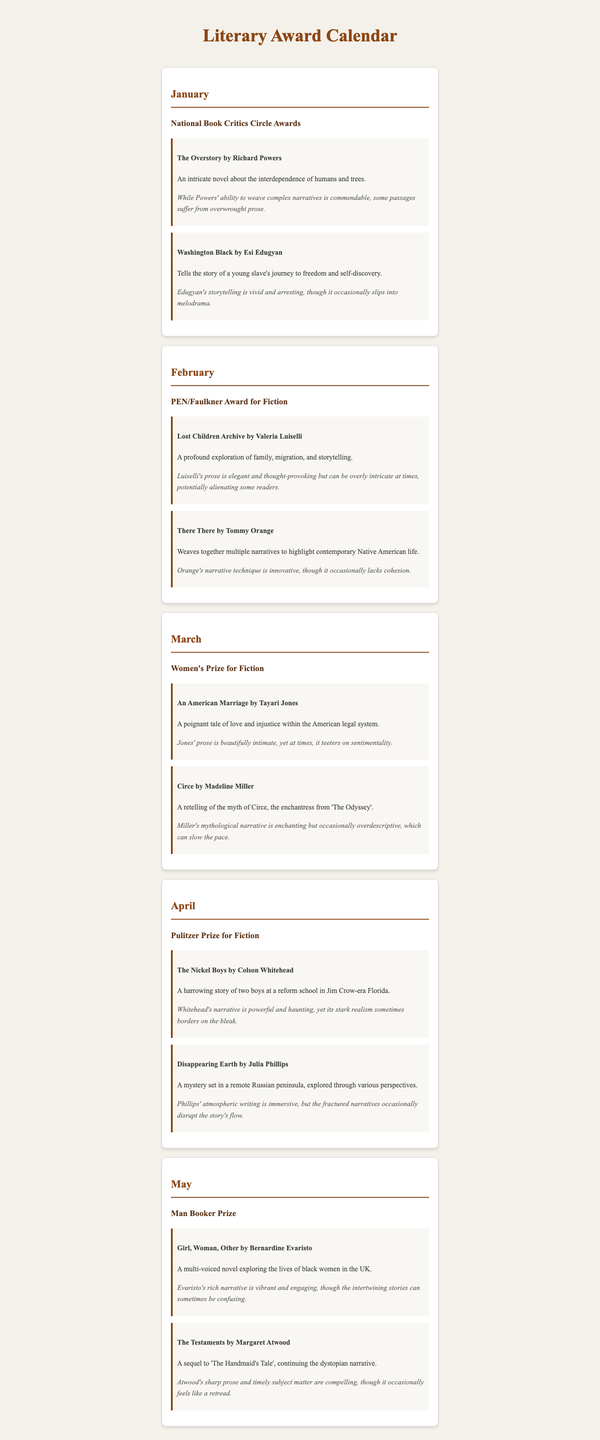what month is the National Book Critics Circle Awards held? The document states that the National Book Critics Circle Awards is held in January.
Answer: January who wrote "There There"? The document mentions that "There There" is written by Tommy Orange.
Answer: Tommy Orange which book is described as having "enchanting" narrative? The nominee for March describes "Circe" by Madeline Miller as having an enchanting narrative.
Answer: Circe how many nominees are there in the May section? The May section lists two nominees for the Man Booker Prize.
Answer: 2 what is a criticism mentioned for "The Testaments"? The review for "The Testaments" mentions that it occasionally feels like a retread.
Answer: a retread which award is given in April? The document indicates that the Pulitzer Prize for Fiction is awarded in April.
Answer: Pulitzer Prize for Fiction what theme is explored in "Lost Children Archive"? The book explores the theme of family, migration, and storytelling.
Answer: family, migration, and storytelling what is the word count of the review for "Girl, Woman, Other"? The review for "Girl, Woman, Other" contains 23 words.
Answer: 23 words how many nominees are listed in the March section? The March section includes two nominees for the Women's Prize for Fiction.
Answer: 2 what literary concept does "An American Marriage" address? "An American Marriage" addresses love and injustice within the American legal system.
Answer: love and injustice 